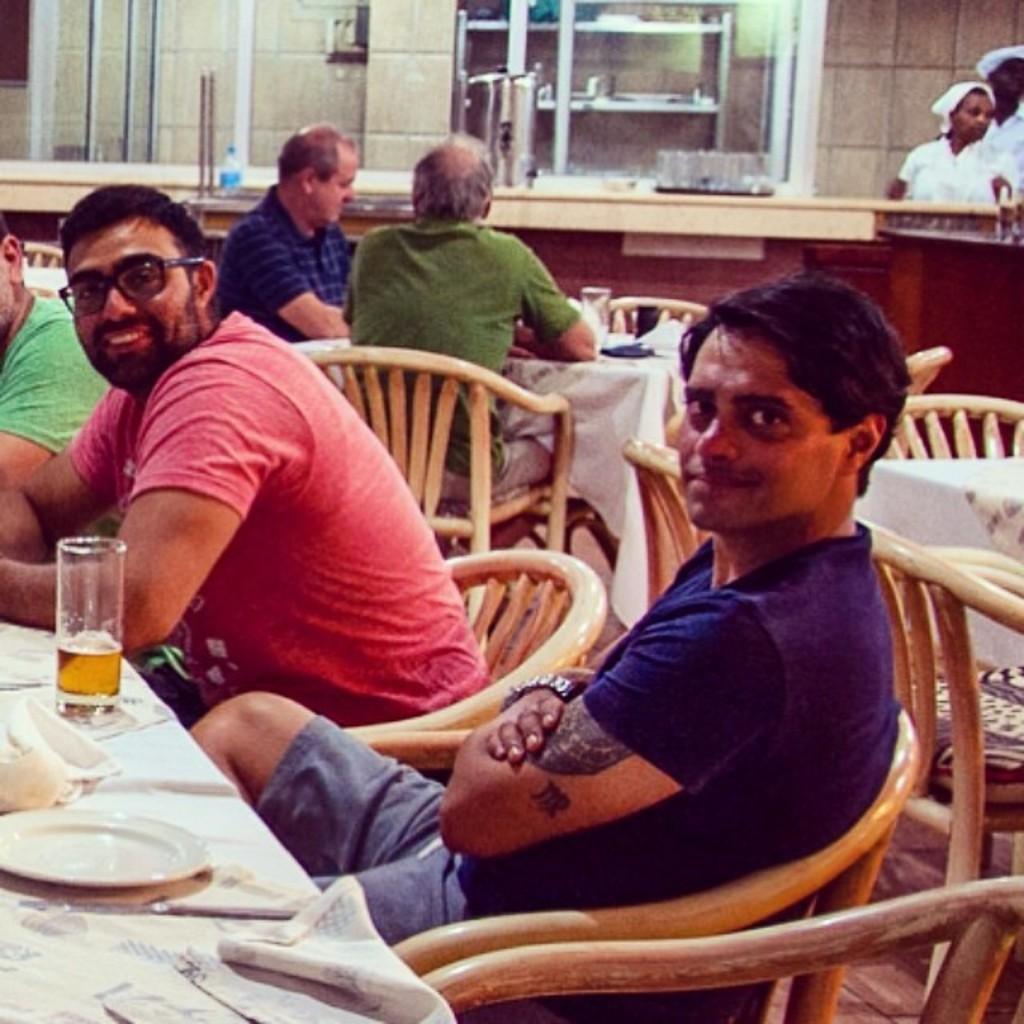Describe this image in one or two sentences. In the image in the center we can see one man sitting and he is smiling. In front of him we can see the table,on table we can see plate,napkin and glass. Beside him we can see another man sitting and he is also smiling. Coming to the background we can see few more persons were sitting and standing. And we can see the wall and some objects around them. 